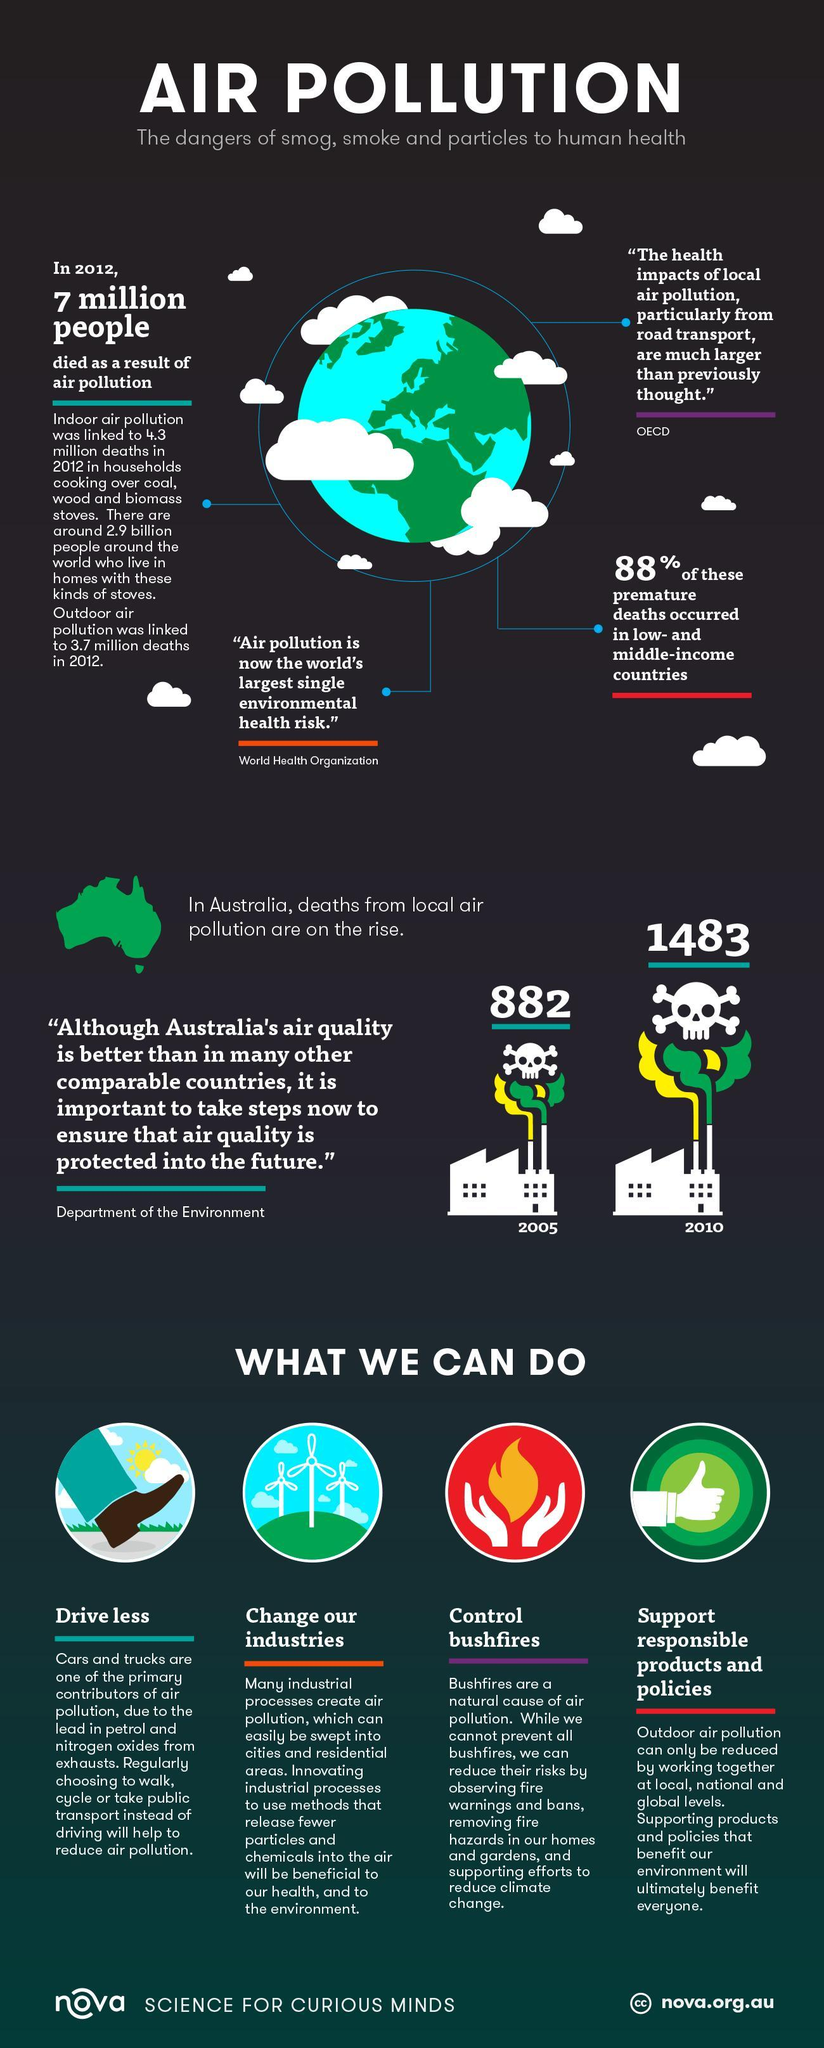How many people died due to air pollution in Australia in 2005?
Answer the question with a short phrase. 882 